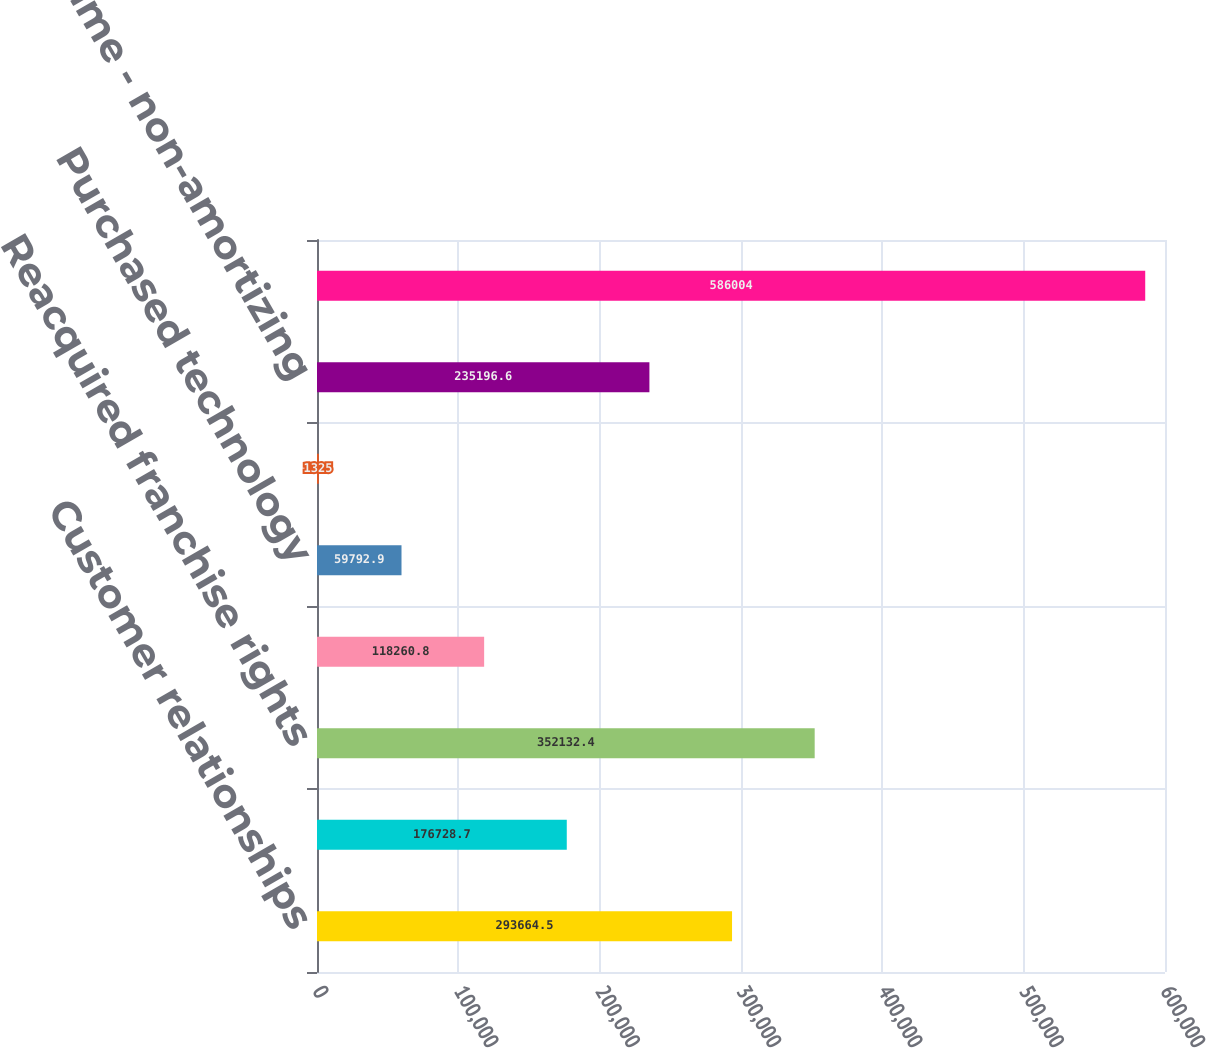<chart> <loc_0><loc_0><loc_500><loc_500><bar_chart><fcel>Customer relationships<fcel>Noncompete agreements<fcel>Reacquired franchise rights<fcel>Franchise agreements<fcel>Purchased technology<fcel>Trade name<fcel>Trade name - non-amortizing<fcel>Total intangible assets<nl><fcel>293664<fcel>176729<fcel>352132<fcel>118261<fcel>59792.9<fcel>1325<fcel>235197<fcel>586004<nl></chart> 